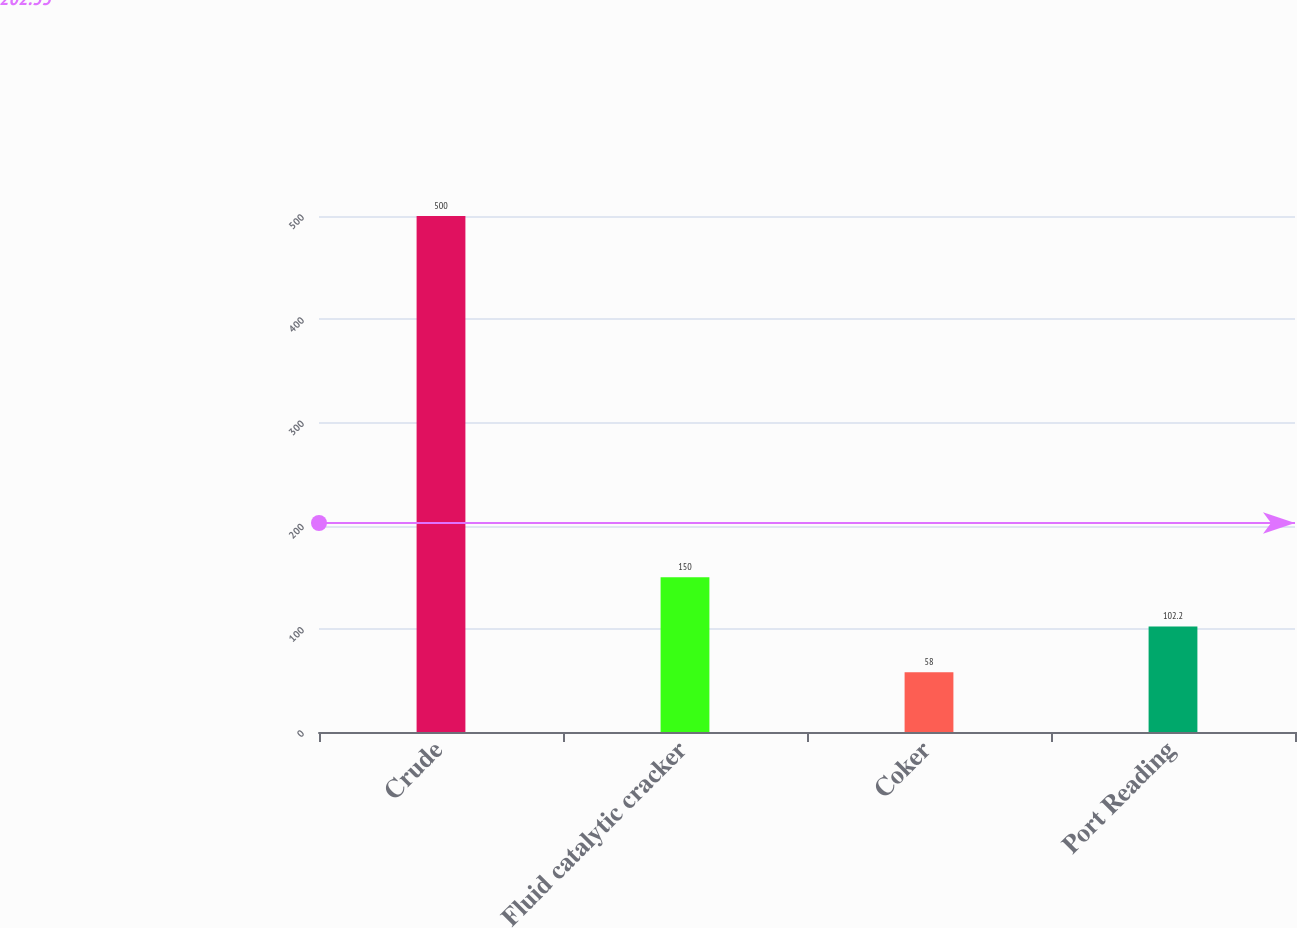Convert chart. <chart><loc_0><loc_0><loc_500><loc_500><bar_chart><fcel>Crude<fcel>Fluid catalytic cracker<fcel>Coker<fcel>Port Reading<nl><fcel>500<fcel>150<fcel>58<fcel>102.2<nl></chart> 